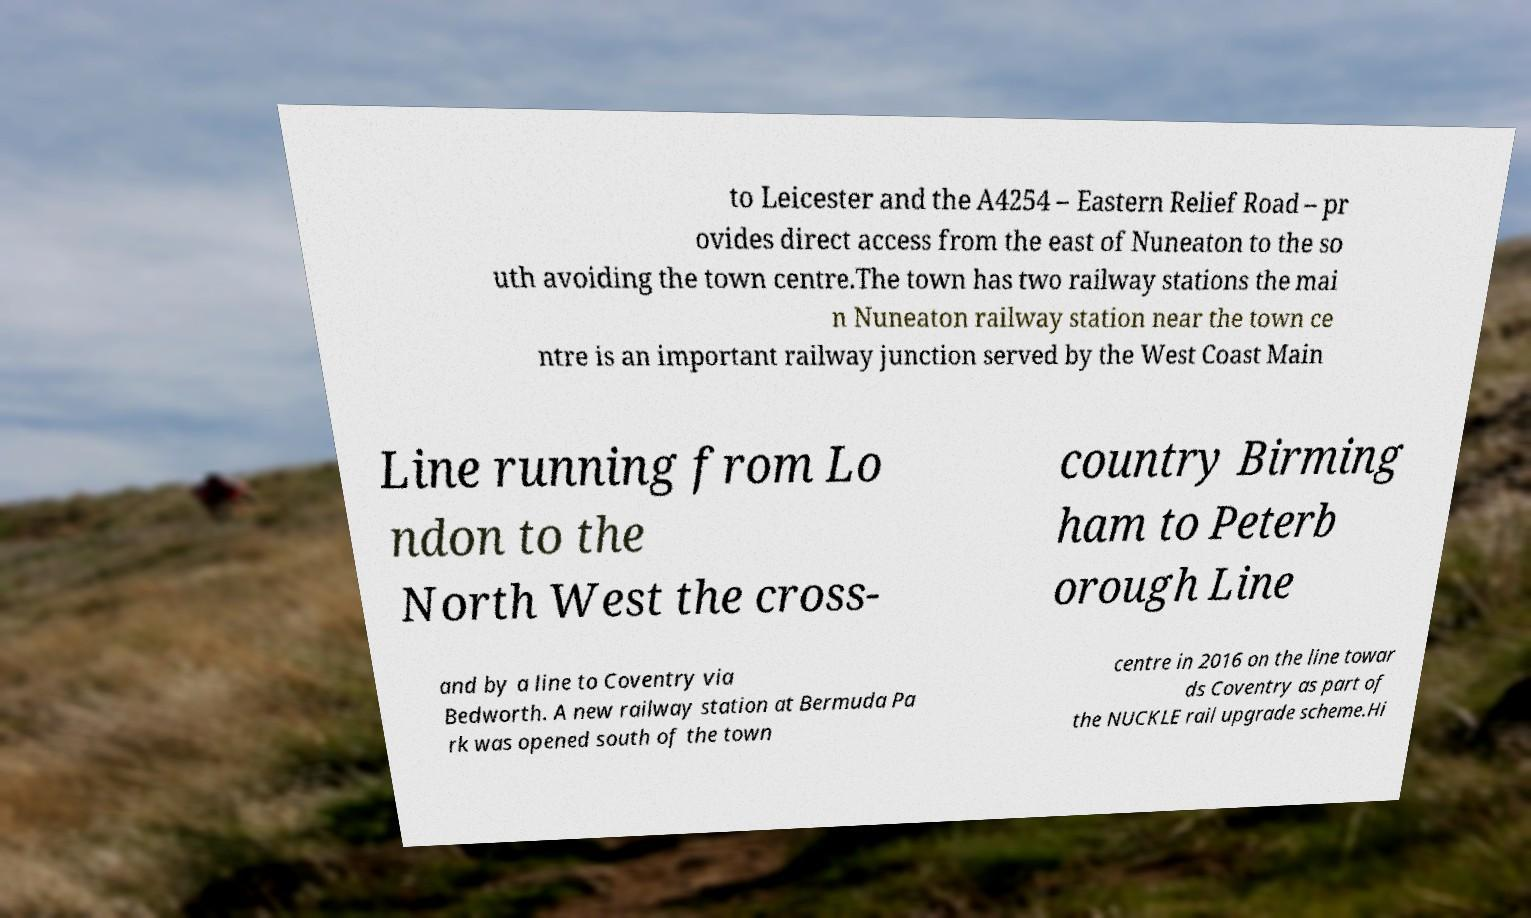What messages or text are displayed in this image? I need them in a readable, typed format. to Leicester and the A4254 – Eastern Relief Road – pr ovides direct access from the east of Nuneaton to the so uth avoiding the town centre.The town has two railway stations the mai n Nuneaton railway station near the town ce ntre is an important railway junction served by the West Coast Main Line running from Lo ndon to the North West the cross- country Birming ham to Peterb orough Line and by a line to Coventry via Bedworth. A new railway station at Bermuda Pa rk was opened south of the town centre in 2016 on the line towar ds Coventry as part of the NUCKLE rail upgrade scheme.Hi 